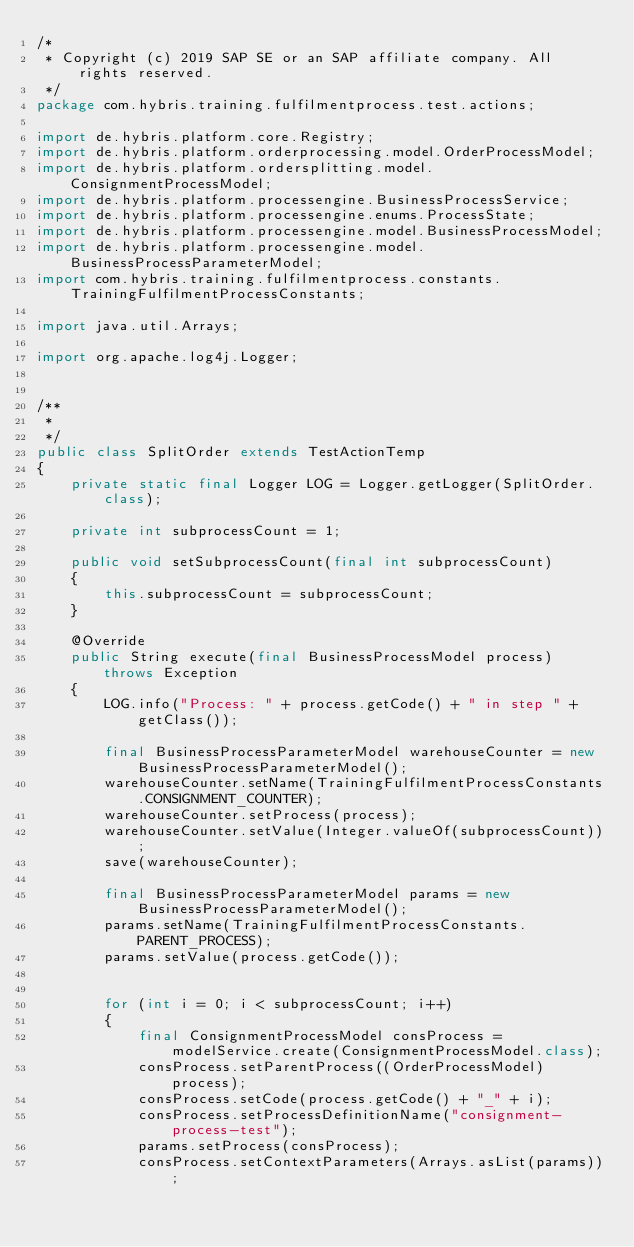Convert code to text. <code><loc_0><loc_0><loc_500><loc_500><_Java_>/*
 * Copyright (c) 2019 SAP SE or an SAP affiliate company. All rights reserved.
 */
package com.hybris.training.fulfilmentprocess.test.actions;

import de.hybris.platform.core.Registry;
import de.hybris.platform.orderprocessing.model.OrderProcessModel;
import de.hybris.platform.ordersplitting.model.ConsignmentProcessModel;
import de.hybris.platform.processengine.BusinessProcessService;
import de.hybris.platform.processengine.enums.ProcessState;
import de.hybris.platform.processengine.model.BusinessProcessModel;
import de.hybris.platform.processengine.model.BusinessProcessParameterModel;
import com.hybris.training.fulfilmentprocess.constants.TrainingFulfilmentProcessConstants;

import java.util.Arrays;

import org.apache.log4j.Logger;


/**
 *
 */
public class SplitOrder extends TestActionTemp
{
	private static final Logger LOG = Logger.getLogger(SplitOrder.class);

	private int subprocessCount = 1;

	public void setSubprocessCount(final int subprocessCount)
	{
		this.subprocessCount = subprocessCount;
	}

	@Override
	public String execute(final BusinessProcessModel process) throws Exception
	{
		LOG.info("Process: " + process.getCode() + " in step " + getClass());

		final BusinessProcessParameterModel warehouseCounter = new BusinessProcessParameterModel();
		warehouseCounter.setName(TrainingFulfilmentProcessConstants.CONSIGNMENT_COUNTER);
		warehouseCounter.setProcess(process);
		warehouseCounter.setValue(Integer.valueOf(subprocessCount));
		save(warehouseCounter);

		final BusinessProcessParameterModel params = new BusinessProcessParameterModel();
		params.setName(TrainingFulfilmentProcessConstants.PARENT_PROCESS);
		params.setValue(process.getCode());


		for (int i = 0; i < subprocessCount; i++)
		{
			final ConsignmentProcessModel consProcess = modelService.create(ConsignmentProcessModel.class);
			consProcess.setParentProcess((OrderProcessModel) process);
			consProcess.setCode(process.getCode() + "_" + i);
			consProcess.setProcessDefinitionName("consignment-process-test");
			params.setProcess(consProcess);
			consProcess.setContextParameters(Arrays.asList(params));</code> 